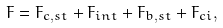Convert formula to latex. <formula><loc_0><loc_0><loc_500><loc_500>F = F _ { c , s t } + F _ { i n t } + F _ { b , s t } + F _ { c i } ,</formula> 